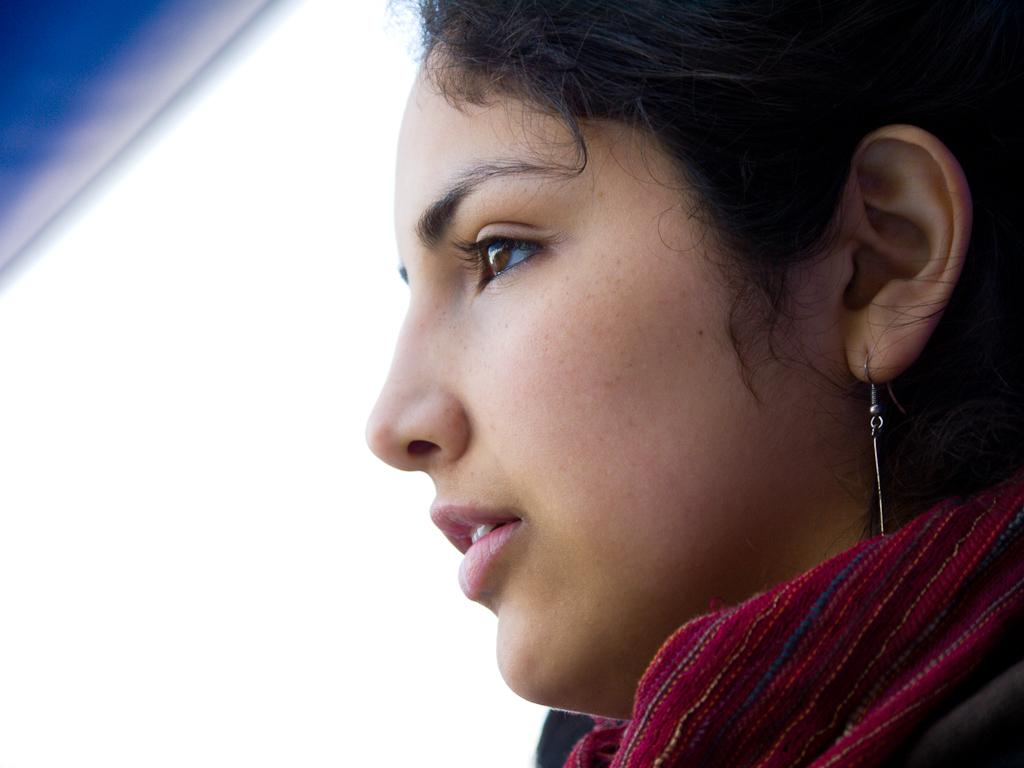Who is present in the image? There is a woman in the image. What is the woman wearing around her neck? The woman is wearing a scarf. What type of jewelry is the woman wearing? The woman is wearing earrings. Can you describe the object in the top left area of the image? Unfortunately, the provided facts do not mention any object in the top left area of the image. What type of fruit is being ordered by the woman in the image? There is no fruit or order present in the image; it only features a woman wearing a scarf and earrings. 